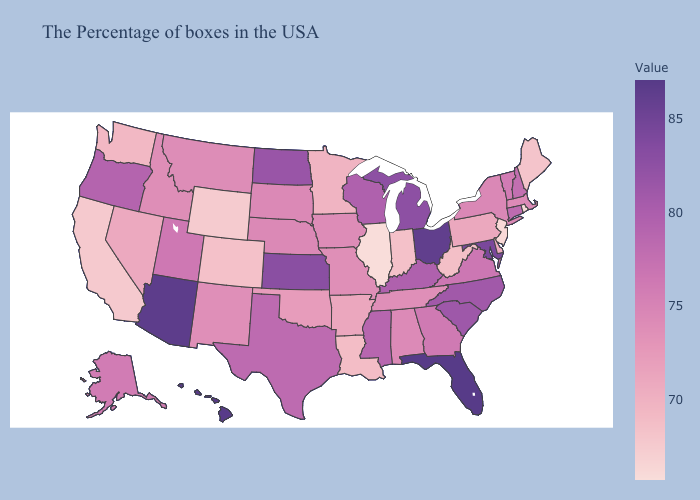Does Missouri have a higher value than North Dakota?
Answer briefly. No. Among the states that border Montana , which have the highest value?
Be succinct. North Dakota. Does Rhode Island have the lowest value in the Northeast?
Write a very short answer. Yes. Which states hav the highest value in the South?
Be succinct. Florida. Which states have the lowest value in the USA?
Give a very brief answer. Illinois. Which states hav the highest value in the West?
Keep it brief. Hawaii. Does Mississippi have the highest value in the USA?
Quick response, please. No. 